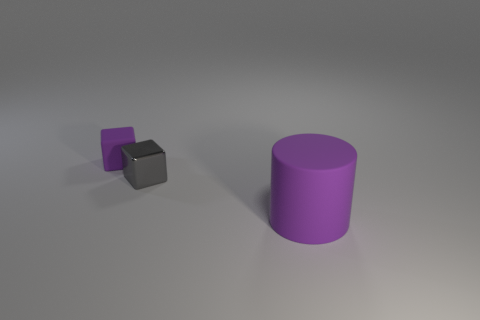Add 2 tiny gray metal objects. How many objects exist? 5 Subtract all blocks. How many objects are left? 1 Add 1 large cyan shiny cubes. How many large cyan shiny cubes exist? 1 Subtract 0 blue cylinders. How many objects are left? 3 Subtract all large gray metallic balls. Subtract all shiny objects. How many objects are left? 2 Add 2 tiny purple rubber cubes. How many tiny purple rubber cubes are left? 3 